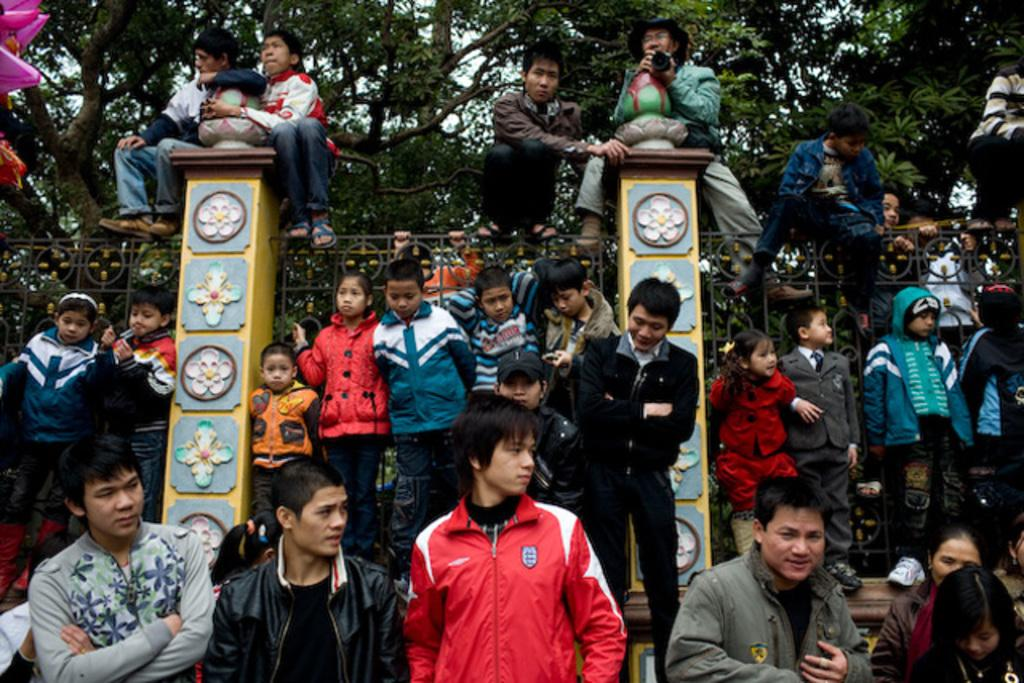What are the people in the image doing? There are people standing and seated in the image. Are there any unique positions or actions being performed by the people? Yes, some people are seated on poles in the image. What else can be seen in the image besides people? Trees are present in the image. Are there any objects or structures that the people are interacting with? Yes, some people are holding a metal fence in the image. What type of branch is being copied by the passenger in the image? There is no branch or passenger present in the image. What type of copy is being made by the people in the image? There is no copying activity being performed by the people in the image. 